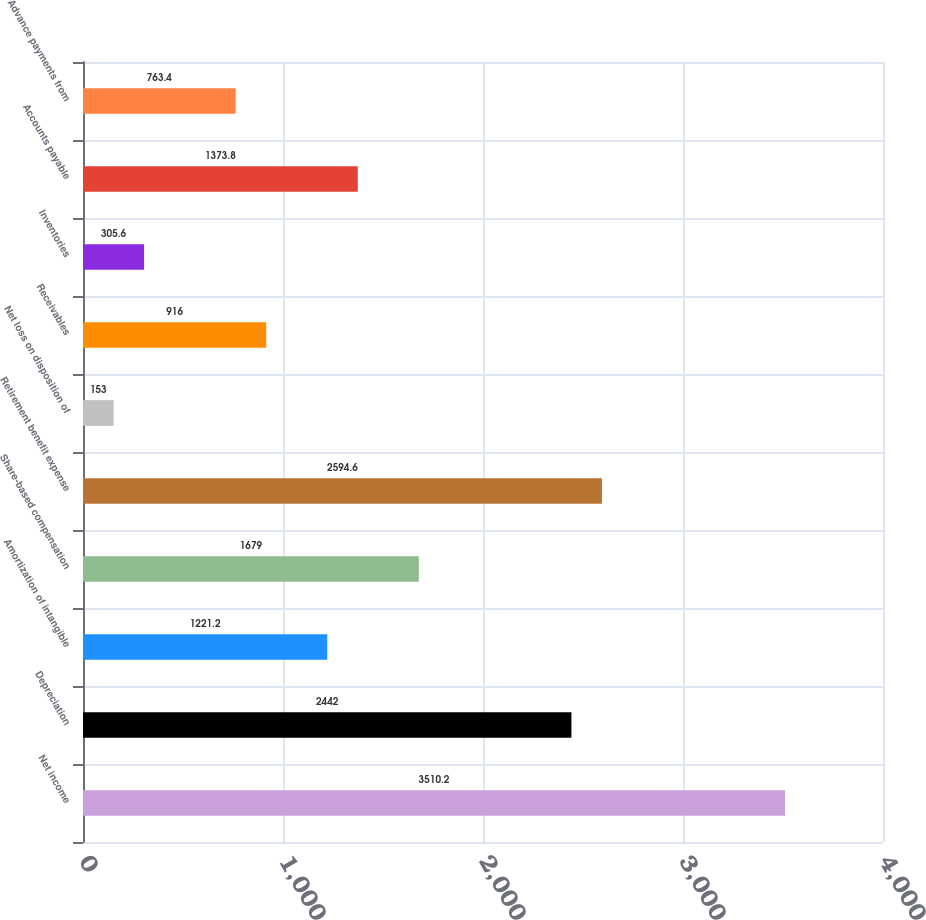Convert chart. <chart><loc_0><loc_0><loc_500><loc_500><bar_chart><fcel>Net income<fcel>Depreciation<fcel>Amortization of intangible<fcel>Share-based compensation<fcel>Retirement benefit expense<fcel>Net loss on disposition of<fcel>Receivables<fcel>Inventories<fcel>Accounts payable<fcel>Advance payments from<nl><fcel>3510.2<fcel>2442<fcel>1221.2<fcel>1679<fcel>2594.6<fcel>153<fcel>916<fcel>305.6<fcel>1373.8<fcel>763.4<nl></chart> 